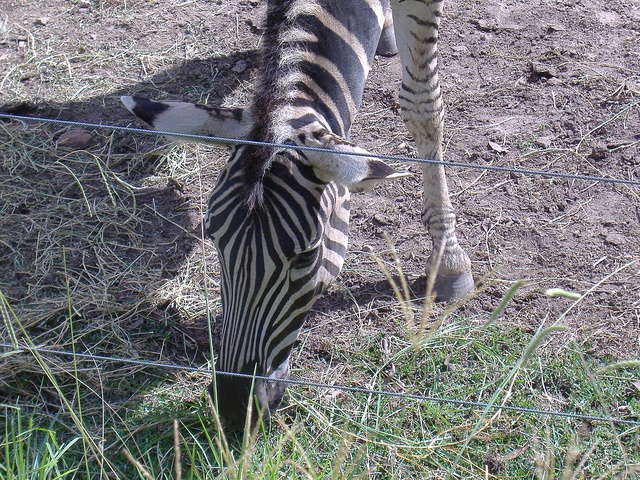Describe the objects in this image and their specific colors. I can see a zebra in gray, black, darkgray, and lightgray tones in this image. 